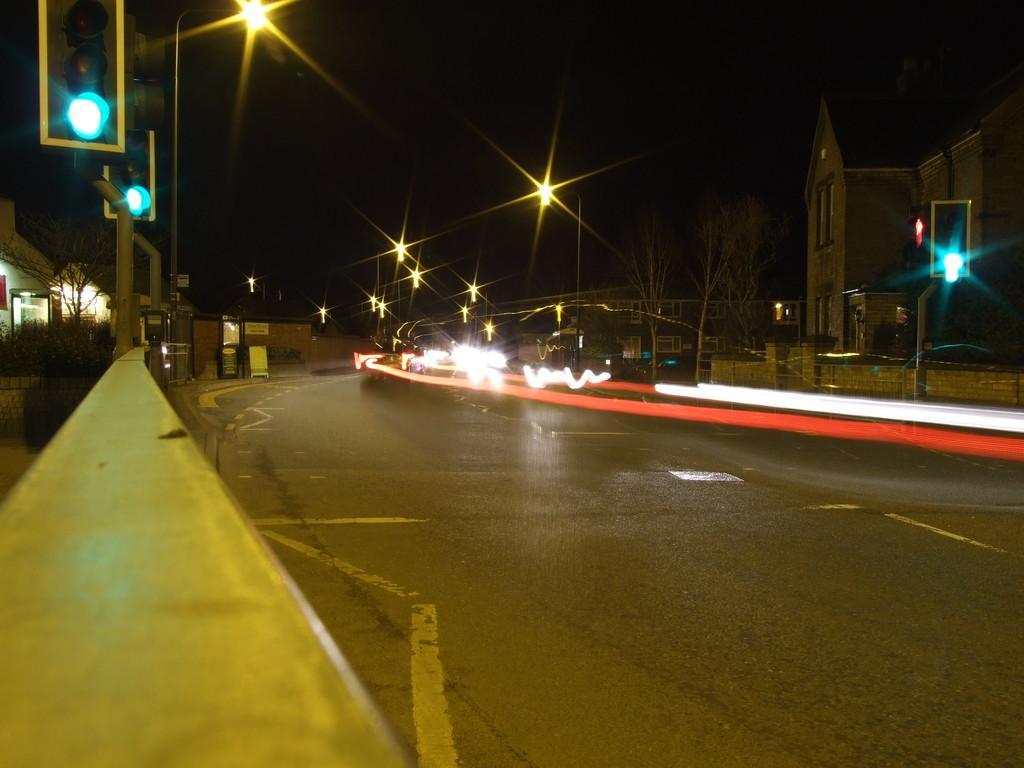How would you summarize this image in a sentence or two? This image consists of a road. To the left, there are traffic poles. To the right, there is a building. At the top, there is a sky. 